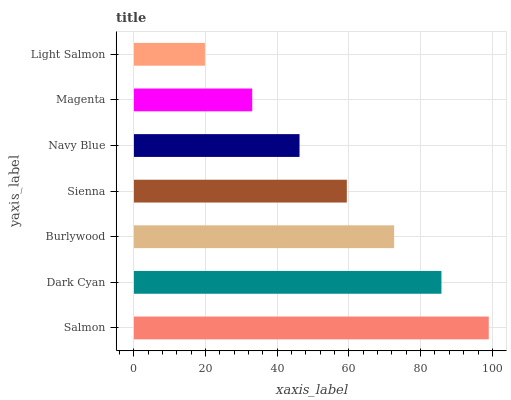Is Light Salmon the minimum?
Answer yes or no. Yes. Is Salmon the maximum?
Answer yes or no. Yes. Is Dark Cyan the minimum?
Answer yes or no. No. Is Dark Cyan the maximum?
Answer yes or no. No. Is Salmon greater than Dark Cyan?
Answer yes or no. Yes. Is Dark Cyan less than Salmon?
Answer yes or no. Yes. Is Dark Cyan greater than Salmon?
Answer yes or no. No. Is Salmon less than Dark Cyan?
Answer yes or no. No. Is Sienna the high median?
Answer yes or no. Yes. Is Sienna the low median?
Answer yes or no. Yes. Is Navy Blue the high median?
Answer yes or no. No. Is Dark Cyan the low median?
Answer yes or no. No. 